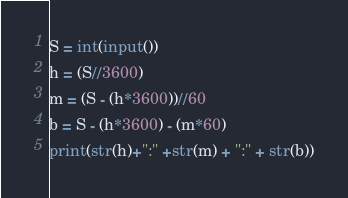Convert code to text. <code><loc_0><loc_0><loc_500><loc_500><_Python_>S = int(input())
h = (S//3600)
m = (S - (h*3600))//60
b = S - (h*3600) - (m*60)
print(str(h)+":" +str(m) + ":" + str(b))</code> 